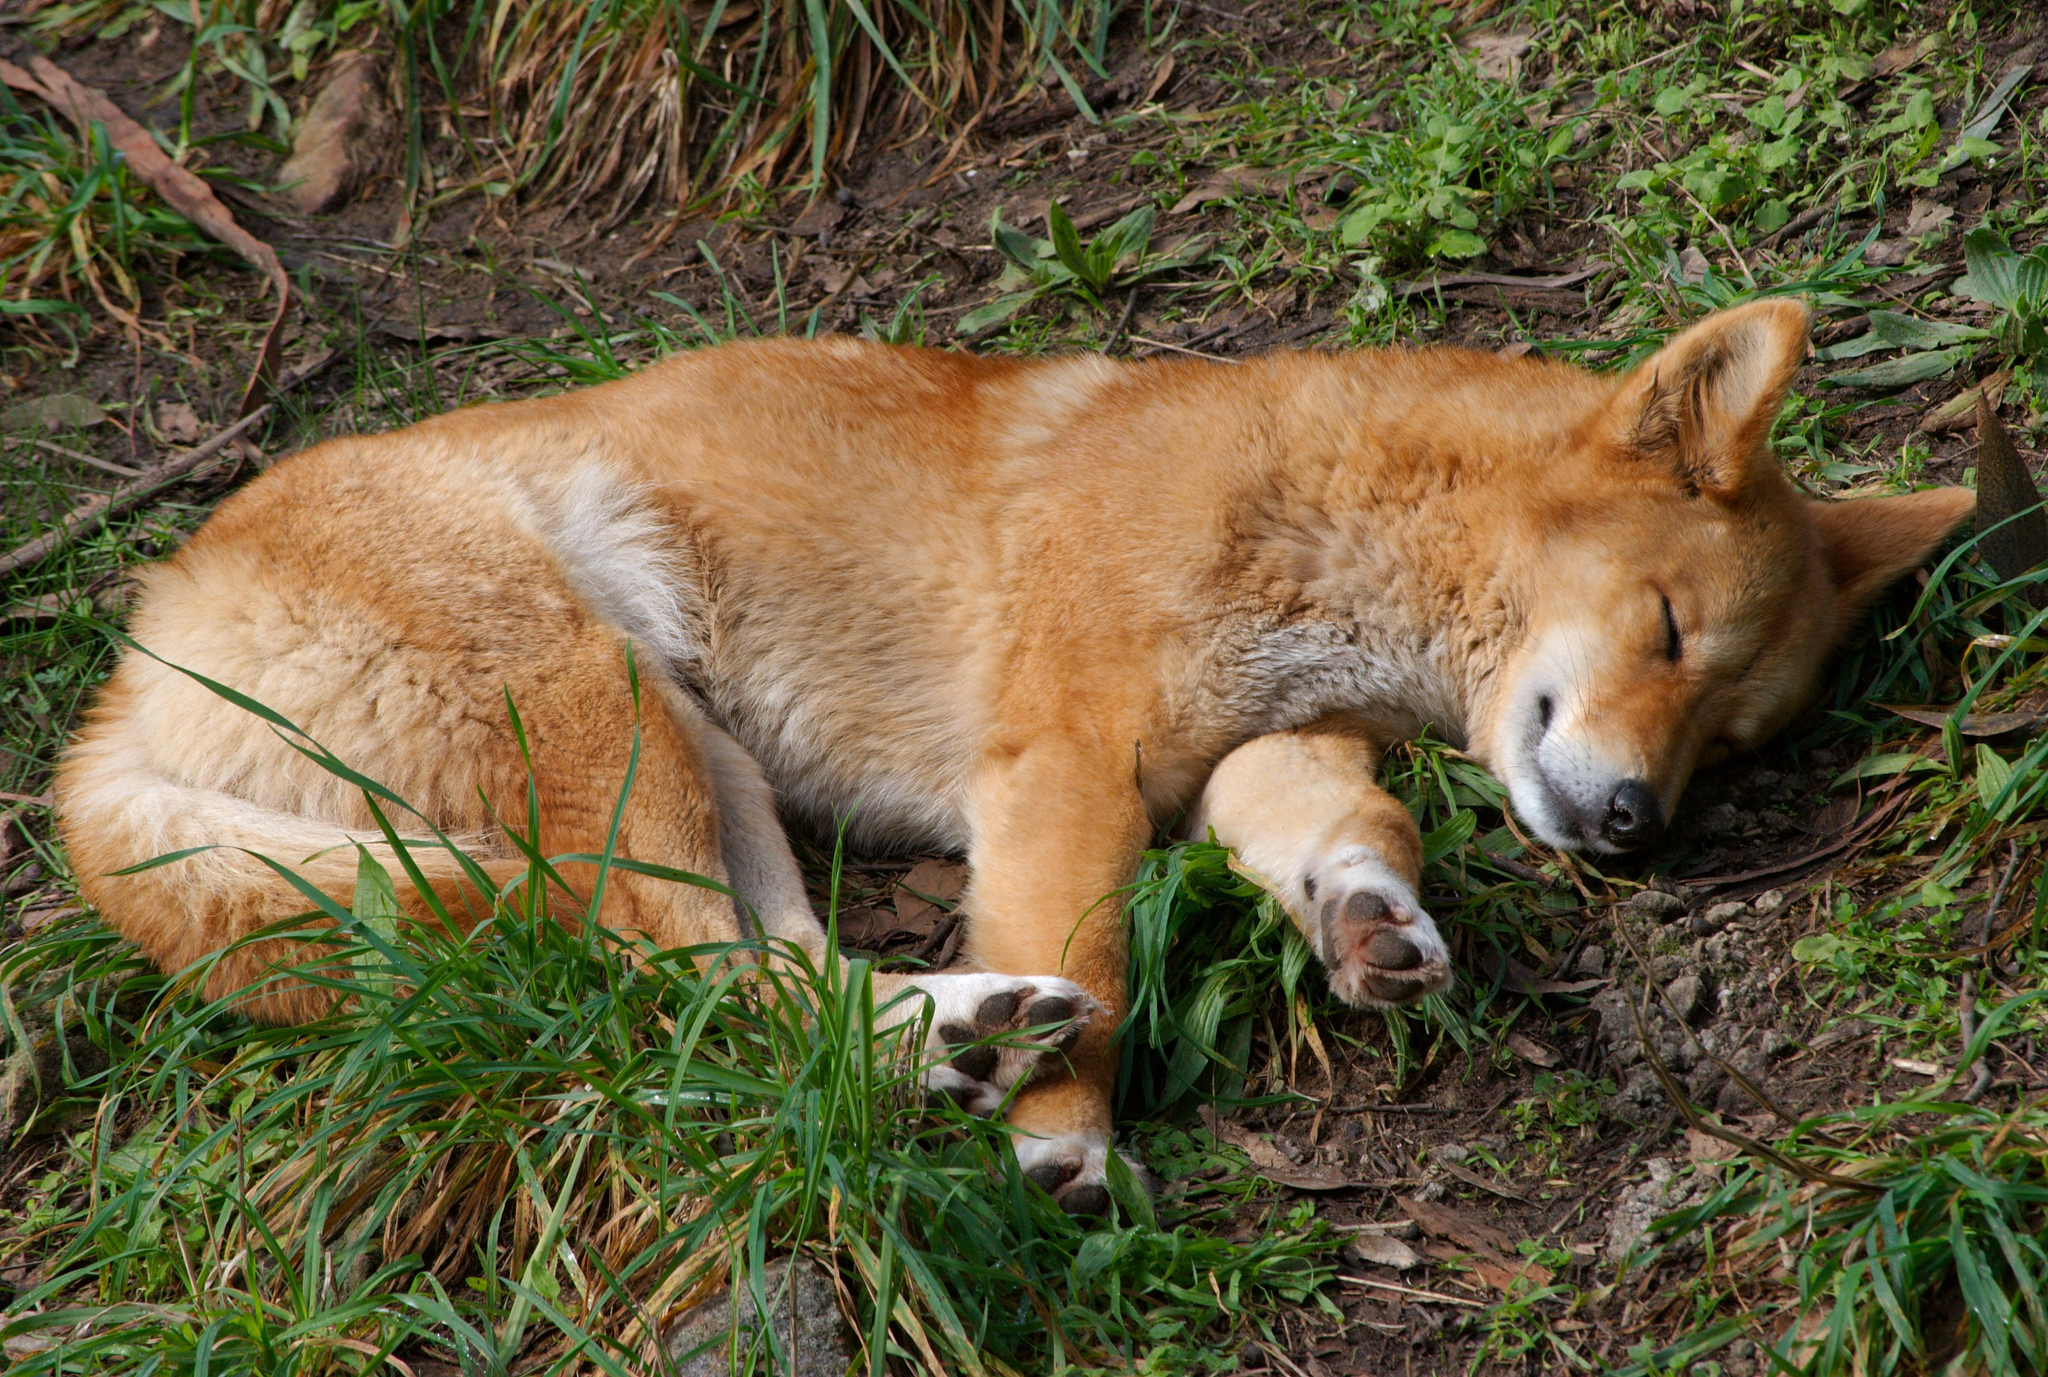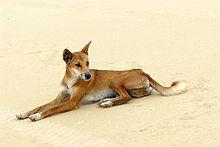The first image is the image on the left, the second image is the image on the right. Considering the images on both sides, is "An image shows one wild dog walking leftward across green grass." valid? Answer yes or no. No. The first image is the image on the left, the second image is the image on the right. Given the left and right images, does the statement "A dog is walking through the grass in one of the images." hold true? Answer yes or no. No. 